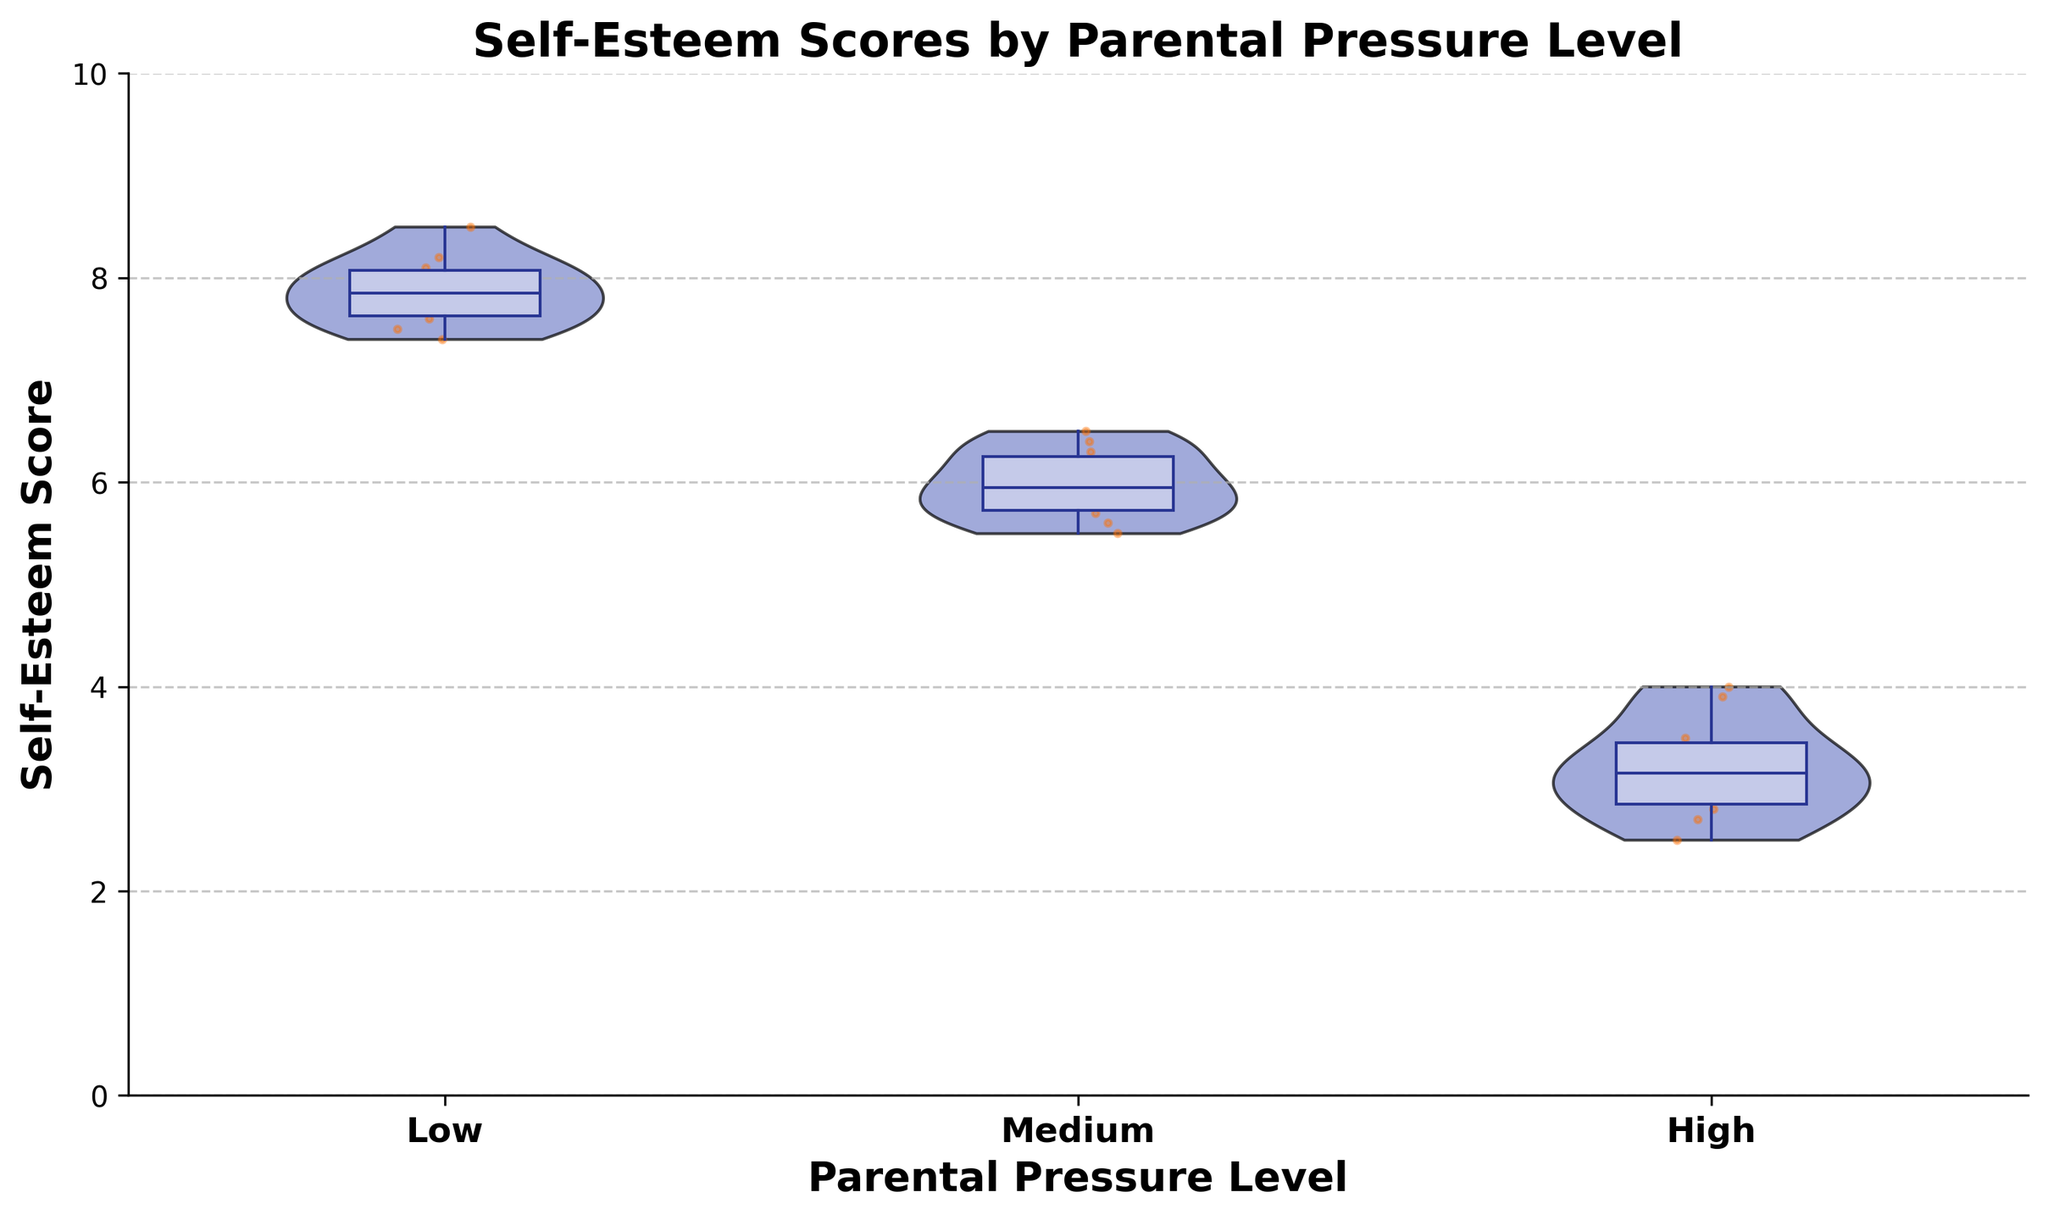What's the title of the figure? The title of the figure is written at the top in bold. It reads "Self-Esteem Scores by Parental Pressure Level."
Answer: Self-Esteem Scores by Parental Pressure Level How many levels of parental pressure are considered in the figure? The x-axis of the figure shows the labels 'Low', 'Medium', and 'High', indicating there are three levels of parental pressure.
Answer: Three Which parental pressure level shows the highest range in self-esteem scores? By examining the spread of the violins, the 'Low' parental pressure level violin is longer, indicating a wider range of self-esteem scores compared to 'Medium' and 'High'.
Answer: Low What parental pressure level has the median self-esteem score closest to 6? The box plot inside the violin for the 'Medium' parental pressure level shows a median line that is closest to 6.
Answer: Medium Which parental pressure level has the most compact distribution of self-esteem scores? The 'High' parental pressure level has the shortest and narrowest violin plot, indicating a more compact distribution.
Answer: High Which parental pressure level shows the highest median self-esteem score? By looking at the box plots inside the violins, 'Low' parental pressure level shows the box plot median line is positioned higher than the others.
Answer: Low Which level of parental pressure shows the lowest self-esteem scores on average? The 'High' parental pressure level has the violins that are shifted lower on the y-axis, indicating a lower average self-esteem score.
Answer: High Compare the spread of self-esteem scores between 'Medium' and 'High' parental pressure levels. Which one is broader? By comparing the widths of the violins, 'Medium' parental pressure level has a broader spread in self-esteem scores than 'High'.
Answer: Medium Among the three groups, which parental pressure level has the maximum value of self-esteem scores? The top of the 'Low' parental pressure level violin reaches up to a higher value than 'Medium' and 'High', indicating it has the maximum self-esteem score.
Answer: Low What is the approximate lowest self-esteem score observed in the 'High' parental pressure level? By looking at the lower end of the 'High' parental pressure level violin, the lowest score appears to be around 2.5.
Answer: Around 2.5 